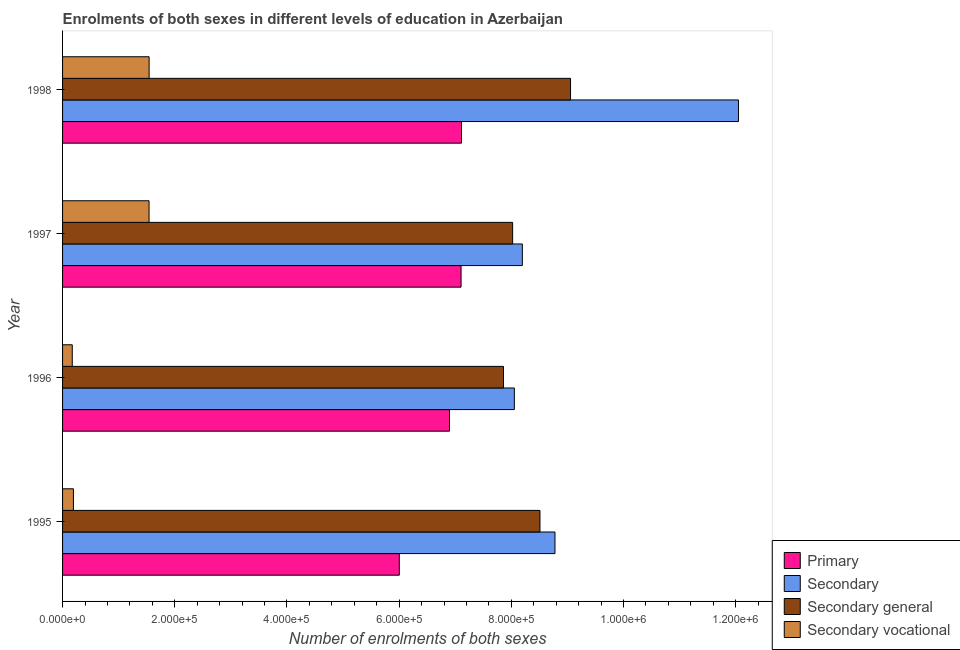Are the number of bars on each tick of the Y-axis equal?
Provide a short and direct response. Yes. How many bars are there on the 3rd tick from the top?
Your response must be concise. 4. How many bars are there on the 4th tick from the bottom?
Your answer should be very brief. 4. In how many cases, is the number of bars for a given year not equal to the number of legend labels?
Give a very brief answer. 0. What is the number of enrolments in secondary education in 1998?
Your answer should be very brief. 1.20e+06. Across all years, what is the maximum number of enrolments in secondary vocational education?
Give a very brief answer. 1.54e+05. Across all years, what is the minimum number of enrolments in primary education?
Your answer should be very brief. 6.00e+05. In which year was the number of enrolments in primary education maximum?
Offer a very short reply. 1998. What is the total number of enrolments in primary education in the graph?
Ensure brevity in your answer.  2.71e+06. What is the difference between the number of enrolments in secondary general education in 1996 and that in 1997?
Give a very brief answer. -1.63e+04. What is the difference between the number of enrolments in secondary education in 1996 and the number of enrolments in secondary vocational education in 1998?
Offer a very short reply. 6.51e+05. What is the average number of enrolments in secondary general education per year?
Your answer should be compact. 8.36e+05. In the year 1998, what is the difference between the number of enrolments in secondary education and number of enrolments in secondary general education?
Your response must be concise. 2.99e+05. In how many years, is the number of enrolments in primary education greater than 920000 ?
Your answer should be very brief. 0. What is the ratio of the number of enrolments in secondary general education in 1996 to that in 1997?
Your answer should be compact. 0.98. Is the number of enrolments in secondary education in 1995 less than that in 1996?
Your answer should be compact. No. What is the difference between the highest and the second highest number of enrolments in secondary education?
Give a very brief answer. 3.27e+05. What is the difference between the highest and the lowest number of enrolments in secondary education?
Keep it short and to the point. 4.00e+05. Is the sum of the number of enrolments in primary education in 1996 and 1998 greater than the maximum number of enrolments in secondary vocational education across all years?
Keep it short and to the point. Yes. What does the 2nd bar from the top in 1997 represents?
Your answer should be very brief. Secondary general. What does the 1st bar from the bottom in 1997 represents?
Provide a succinct answer. Primary. Is it the case that in every year, the sum of the number of enrolments in primary education and number of enrolments in secondary education is greater than the number of enrolments in secondary general education?
Provide a short and direct response. Yes. How many bars are there?
Give a very brief answer. 16. Are all the bars in the graph horizontal?
Give a very brief answer. Yes. Are the values on the major ticks of X-axis written in scientific E-notation?
Your response must be concise. Yes. Where does the legend appear in the graph?
Your response must be concise. Bottom right. How many legend labels are there?
Give a very brief answer. 4. How are the legend labels stacked?
Give a very brief answer. Vertical. What is the title of the graph?
Keep it short and to the point. Enrolments of both sexes in different levels of education in Azerbaijan. What is the label or title of the X-axis?
Provide a short and direct response. Number of enrolments of both sexes. What is the Number of enrolments of both sexes in Primary in 1995?
Your answer should be compact. 6.00e+05. What is the Number of enrolments of both sexes in Secondary in 1995?
Keep it short and to the point. 8.78e+05. What is the Number of enrolments of both sexes in Secondary general in 1995?
Offer a terse response. 8.51e+05. What is the Number of enrolments of both sexes of Secondary vocational in 1995?
Keep it short and to the point. 1.94e+04. What is the Number of enrolments of both sexes of Primary in 1996?
Your response must be concise. 6.90e+05. What is the Number of enrolments of both sexes in Secondary in 1996?
Give a very brief answer. 8.05e+05. What is the Number of enrolments of both sexes of Secondary general in 1996?
Ensure brevity in your answer.  7.86e+05. What is the Number of enrolments of both sexes of Secondary vocational in 1996?
Offer a very short reply. 1.73e+04. What is the Number of enrolments of both sexes of Primary in 1997?
Your answer should be compact. 7.10e+05. What is the Number of enrolments of both sexes of Secondary in 1997?
Make the answer very short. 8.20e+05. What is the Number of enrolments of both sexes of Secondary general in 1997?
Offer a terse response. 8.02e+05. What is the Number of enrolments of both sexes in Secondary vocational in 1997?
Your response must be concise. 1.54e+05. What is the Number of enrolments of both sexes in Primary in 1998?
Offer a very short reply. 7.11e+05. What is the Number of enrolments of both sexes in Secondary in 1998?
Offer a very short reply. 1.20e+06. What is the Number of enrolments of both sexes of Secondary general in 1998?
Keep it short and to the point. 9.06e+05. What is the Number of enrolments of both sexes in Secondary vocational in 1998?
Your answer should be very brief. 1.54e+05. Across all years, what is the maximum Number of enrolments of both sexes of Primary?
Give a very brief answer. 7.11e+05. Across all years, what is the maximum Number of enrolments of both sexes in Secondary?
Provide a short and direct response. 1.20e+06. Across all years, what is the maximum Number of enrolments of both sexes in Secondary general?
Your answer should be very brief. 9.06e+05. Across all years, what is the maximum Number of enrolments of both sexes of Secondary vocational?
Keep it short and to the point. 1.54e+05. Across all years, what is the minimum Number of enrolments of both sexes of Primary?
Give a very brief answer. 6.00e+05. Across all years, what is the minimum Number of enrolments of both sexes of Secondary?
Ensure brevity in your answer.  8.05e+05. Across all years, what is the minimum Number of enrolments of both sexes in Secondary general?
Offer a very short reply. 7.86e+05. Across all years, what is the minimum Number of enrolments of both sexes of Secondary vocational?
Offer a very short reply. 1.73e+04. What is the total Number of enrolments of both sexes of Primary in the graph?
Keep it short and to the point. 2.71e+06. What is the total Number of enrolments of both sexes of Secondary in the graph?
Ensure brevity in your answer.  3.71e+06. What is the total Number of enrolments of both sexes of Secondary general in the graph?
Give a very brief answer. 3.34e+06. What is the total Number of enrolments of both sexes in Secondary vocational in the graph?
Your answer should be compact. 3.45e+05. What is the difference between the Number of enrolments of both sexes in Primary in 1995 and that in 1996?
Give a very brief answer. -8.94e+04. What is the difference between the Number of enrolments of both sexes in Secondary in 1995 and that in 1996?
Your answer should be very brief. 7.24e+04. What is the difference between the Number of enrolments of both sexes in Secondary general in 1995 and that in 1996?
Keep it short and to the point. 6.50e+04. What is the difference between the Number of enrolments of both sexes of Secondary vocational in 1995 and that in 1996?
Your response must be concise. 2070. What is the difference between the Number of enrolments of both sexes in Primary in 1995 and that in 1997?
Your answer should be very brief. -1.10e+05. What is the difference between the Number of enrolments of both sexes in Secondary in 1995 and that in 1997?
Offer a terse response. 5.82e+04. What is the difference between the Number of enrolments of both sexes in Secondary general in 1995 and that in 1997?
Provide a succinct answer. 4.87e+04. What is the difference between the Number of enrolments of both sexes of Secondary vocational in 1995 and that in 1997?
Your answer should be compact. -1.35e+05. What is the difference between the Number of enrolments of both sexes in Primary in 1995 and that in 1998?
Give a very brief answer. -1.11e+05. What is the difference between the Number of enrolments of both sexes of Secondary in 1995 and that in 1998?
Your response must be concise. -3.27e+05. What is the difference between the Number of enrolments of both sexes in Secondary general in 1995 and that in 1998?
Provide a succinct answer. -5.45e+04. What is the difference between the Number of enrolments of both sexes in Secondary vocational in 1995 and that in 1998?
Your answer should be very brief. -1.35e+05. What is the difference between the Number of enrolments of both sexes in Primary in 1996 and that in 1997?
Your answer should be compact. -2.06e+04. What is the difference between the Number of enrolments of both sexes in Secondary in 1996 and that in 1997?
Your answer should be very brief. -1.42e+04. What is the difference between the Number of enrolments of both sexes in Secondary general in 1996 and that in 1997?
Provide a succinct answer. -1.63e+04. What is the difference between the Number of enrolments of both sexes of Secondary vocational in 1996 and that in 1997?
Ensure brevity in your answer.  -1.37e+05. What is the difference between the Number of enrolments of both sexes in Primary in 1996 and that in 1998?
Your response must be concise. -2.14e+04. What is the difference between the Number of enrolments of both sexes in Secondary in 1996 and that in 1998?
Provide a short and direct response. -4.00e+05. What is the difference between the Number of enrolments of both sexes in Secondary general in 1996 and that in 1998?
Your response must be concise. -1.20e+05. What is the difference between the Number of enrolments of both sexes in Secondary vocational in 1996 and that in 1998?
Your response must be concise. -1.37e+05. What is the difference between the Number of enrolments of both sexes of Primary in 1997 and that in 1998?
Your response must be concise. -738. What is the difference between the Number of enrolments of both sexes of Secondary in 1997 and that in 1998?
Keep it short and to the point. -3.85e+05. What is the difference between the Number of enrolments of both sexes in Secondary general in 1997 and that in 1998?
Your answer should be compact. -1.03e+05. What is the difference between the Number of enrolments of both sexes in Secondary vocational in 1997 and that in 1998?
Offer a very short reply. -114. What is the difference between the Number of enrolments of both sexes of Primary in 1995 and the Number of enrolments of both sexes of Secondary in 1996?
Your answer should be compact. -2.05e+05. What is the difference between the Number of enrolments of both sexes in Primary in 1995 and the Number of enrolments of both sexes in Secondary general in 1996?
Make the answer very short. -1.86e+05. What is the difference between the Number of enrolments of both sexes of Primary in 1995 and the Number of enrolments of both sexes of Secondary vocational in 1996?
Your answer should be compact. 5.83e+05. What is the difference between the Number of enrolments of both sexes of Secondary in 1995 and the Number of enrolments of both sexes of Secondary general in 1996?
Your answer should be compact. 9.18e+04. What is the difference between the Number of enrolments of both sexes of Secondary in 1995 and the Number of enrolments of both sexes of Secondary vocational in 1996?
Your answer should be compact. 8.61e+05. What is the difference between the Number of enrolments of both sexes of Secondary general in 1995 and the Number of enrolments of both sexes of Secondary vocational in 1996?
Offer a very short reply. 8.34e+05. What is the difference between the Number of enrolments of both sexes in Primary in 1995 and the Number of enrolments of both sexes in Secondary in 1997?
Offer a terse response. -2.19e+05. What is the difference between the Number of enrolments of both sexes in Primary in 1995 and the Number of enrolments of both sexes in Secondary general in 1997?
Make the answer very short. -2.02e+05. What is the difference between the Number of enrolments of both sexes of Primary in 1995 and the Number of enrolments of both sexes of Secondary vocational in 1997?
Keep it short and to the point. 4.46e+05. What is the difference between the Number of enrolments of both sexes of Secondary in 1995 and the Number of enrolments of both sexes of Secondary general in 1997?
Keep it short and to the point. 7.55e+04. What is the difference between the Number of enrolments of both sexes of Secondary in 1995 and the Number of enrolments of both sexes of Secondary vocational in 1997?
Offer a very short reply. 7.24e+05. What is the difference between the Number of enrolments of both sexes of Secondary general in 1995 and the Number of enrolments of both sexes of Secondary vocational in 1997?
Give a very brief answer. 6.97e+05. What is the difference between the Number of enrolments of both sexes in Primary in 1995 and the Number of enrolments of both sexes in Secondary in 1998?
Give a very brief answer. -6.05e+05. What is the difference between the Number of enrolments of both sexes in Primary in 1995 and the Number of enrolments of both sexes in Secondary general in 1998?
Make the answer very short. -3.05e+05. What is the difference between the Number of enrolments of both sexes in Primary in 1995 and the Number of enrolments of both sexes in Secondary vocational in 1998?
Your response must be concise. 4.46e+05. What is the difference between the Number of enrolments of both sexes in Secondary in 1995 and the Number of enrolments of both sexes in Secondary general in 1998?
Give a very brief answer. -2.77e+04. What is the difference between the Number of enrolments of both sexes in Secondary in 1995 and the Number of enrolments of both sexes in Secondary vocational in 1998?
Your response must be concise. 7.24e+05. What is the difference between the Number of enrolments of both sexes in Secondary general in 1995 and the Number of enrolments of both sexes in Secondary vocational in 1998?
Offer a very short reply. 6.97e+05. What is the difference between the Number of enrolments of both sexes in Primary in 1996 and the Number of enrolments of both sexes in Secondary in 1997?
Provide a succinct answer. -1.30e+05. What is the difference between the Number of enrolments of both sexes of Primary in 1996 and the Number of enrolments of both sexes of Secondary general in 1997?
Offer a terse response. -1.13e+05. What is the difference between the Number of enrolments of both sexes of Primary in 1996 and the Number of enrolments of both sexes of Secondary vocational in 1997?
Make the answer very short. 5.36e+05. What is the difference between the Number of enrolments of both sexes of Secondary in 1996 and the Number of enrolments of both sexes of Secondary general in 1997?
Ensure brevity in your answer.  3044. What is the difference between the Number of enrolments of both sexes of Secondary in 1996 and the Number of enrolments of both sexes of Secondary vocational in 1997?
Your answer should be compact. 6.51e+05. What is the difference between the Number of enrolments of both sexes in Secondary general in 1996 and the Number of enrolments of both sexes in Secondary vocational in 1997?
Offer a very short reply. 6.32e+05. What is the difference between the Number of enrolments of both sexes in Primary in 1996 and the Number of enrolments of both sexes in Secondary in 1998?
Your answer should be compact. -5.15e+05. What is the difference between the Number of enrolments of both sexes in Primary in 1996 and the Number of enrolments of both sexes in Secondary general in 1998?
Your answer should be very brief. -2.16e+05. What is the difference between the Number of enrolments of both sexes in Primary in 1996 and the Number of enrolments of both sexes in Secondary vocational in 1998?
Offer a terse response. 5.35e+05. What is the difference between the Number of enrolments of both sexes in Secondary in 1996 and the Number of enrolments of both sexes in Secondary general in 1998?
Your response must be concise. -1.00e+05. What is the difference between the Number of enrolments of both sexes of Secondary in 1996 and the Number of enrolments of both sexes of Secondary vocational in 1998?
Your answer should be very brief. 6.51e+05. What is the difference between the Number of enrolments of both sexes of Secondary general in 1996 and the Number of enrolments of both sexes of Secondary vocational in 1998?
Your response must be concise. 6.32e+05. What is the difference between the Number of enrolments of both sexes in Primary in 1997 and the Number of enrolments of both sexes in Secondary in 1998?
Make the answer very short. -4.95e+05. What is the difference between the Number of enrolments of both sexes of Primary in 1997 and the Number of enrolments of both sexes of Secondary general in 1998?
Give a very brief answer. -1.95e+05. What is the difference between the Number of enrolments of both sexes in Primary in 1997 and the Number of enrolments of both sexes in Secondary vocational in 1998?
Ensure brevity in your answer.  5.56e+05. What is the difference between the Number of enrolments of both sexes of Secondary in 1997 and the Number of enrolments of both sexes of Secondary general in 1998?
Your answer should be compact. -8.59e+04. What is the difference between the Number of enrolments of both sexes in Secondary in 1997 and the Number of enrolments of both sexes in Secondary vocational in 1998?
Offer a very short reply. 6.65e+05. What is the difference between the Number of enrolments of both sexes in Secondary general in 1997 and the Number of enrolments of both sexes in Secondary vocational in 1998?
Keep it short and to the point. 6.48e+05. What is the average Number of enrolments of both sexes in Primary per year?
Your answer should be very brief. 6.78e+05. What is the average Number of enrolments of both sexes of Secondary per year?
Provide a short and direct response. 9.27e+05. What is the average Number of enrolments of both sexes of Secondary general per year?
Offer a terse response. 8.36e+05. What is the average Number of enrolments of both sexes of Secondary vocational per year?
Give a very brief answer. 8.63e+04. In the year 1995, what is the difference between the Number of enrolments of both sexes of Primary and Number of enrolments of both sexes of Secondary?
Offer a very short reply. -2.77e+05. In the year 1995, what is the difference between the Number of enrolments of both sexes in Primary and Number of enrolments of both sexes in Secondary general?
Provide a succinct answer. -2.51e+05. In the year 1995, what is the difference between the Number of enrolments of both sexes of Primary and Number of enrolments of both sexes of Secondary vocational?
Provide a short and direct response. 5.81e+05. In the year 1995, what is the difference between the Number of enrolments of both sexes of Secondary and Number of enrolments of both sexes of Secondary general?
Your response must be concise. 2.68e+04. In the year 1995, what is the difference between the Number of enrolments of both sexes of Secondary and Number of enrolments of both sexes of Secondary vocational?
Your answer should be compact. 8.58e+05. In the year 1995, what is the difference between the Number of enrolments of both sexes of Secondary general and Number of enrolments of both sexes of Secondary vocational?
Provide a succinct answer. 8.32e+05. In the year 1996, what is the difference between the Number of enrolments of both sexes in Primary and Number of enrolments of both sexes in Secondary?
Your response must be concise. -1.16e+05. In the year 1996, what is the difference between the Number of enrolments of both sexes in Primary and Number of enrolments of both sexes in Secondary general?
Make the answer very short. -9.63e+04. In the year 1996, what is the difference between the Number of enrolments of both sexes in Primary and Number of enrolments of both sexes in Secondary vocational?
Ensure brevity in your answer.  6.72e+05. In the year 1996, what is the difference between the Number of enrolments of both sexes of Secondary and Number of enrolments of both sexes of Secondary general?
Keep it short and to the point. 1.94e+04. In the year 1996, what is the difference between the Number of enrolments of both sexes of Secondary and Number of enrolments of both sexes of Secondary vocational?
Provide a succinct answer. 7.88e+05. In the year 1996, what is the difference between the Number of enrolments of both sexes in Secondary general and Number of enrolments of both sexes in Secondary vocational?
Offer a terse response. 7.69e+05. In the year 1997, what is the difference between the Number of enrolments of both sexes in Primary and Number of enrolments of both sexes in Secondary?
Keep it short and to the point. -1.09e+05. In the year 1997, what is the difference between the Number of enrolments of both sexes in Primary and Number of enrolments of both sexes in Secondary general?
Your response must be concise. -9.19e+04. In the year 1997, what is the difference between the Number of enrolments of both sexes in Primary and Number of enrolments of both sexes in Secondary vocational?
Your answer should be compact. 5.56e+05. In the year 1997, what is the difference between the Number of enrolments of both sexes of Secondary and Number of enrolments of both sexes of Secondary general?
Provide a succinct answer. 1.73e+04. In the year 1997, what is the difference between the Number of enrolments of both sexes of Secondary and Number of enrolments of both sexes of Secondary vocational?
Provide a short and direct response. 6.65e+05. In the year 1997, what is the difference between the Number of enrolments of both sexes of Secondary general and Number of enrolments of both sexes of Secondary vocational?
Your answer should be compact. 6.48e+05. In the year 1998, what is the difference between the Number of enrolments of both sexes in Primary and Number of enrolments of both sexes in Secondary?
Give a very brief answer. -4.94e+05. In the year 1998, what is the difference between the Number of enrolments of both sexes of Primary and Number of enrolments of both sexes of Secondary general?
Provide a succinct answer. -1.94e+05. In the year 1998, what is the difference between the Number of enrolments of both sexes in Primary and Number of enrolments of both sexes in Secondary vocational?
Offer a terse response. 5.57e+05. In the year 1998, what is the difference between the Number of enrolments of both sexes in Secondary and Number of enrolments of both sexes in Secondary general?
Your answer should be very brief. 2.99e+05. In the year 1998, what is the difference between the Number of enrolments of both sexes of Secondary and Number of enrolments of both sexes of Secondary vocational?
Keep it short and to the point. 1.05e+06. In the year 1998, what is the difference between the Number of enrolments of both sexes in Secondary general and Number of enrolments of both sexes in Secondary vocational?
Offer a terse response. 7.51e+05. What is the ratio of the Number of enrolments of both sexes in Primary in 1995 to that in 1996?
Ensure brevity in your answer.  0.87. What is the ratio of the Number of enrolments of both sexes in Secondary in 1995 to that in 1996?
Provide a short and direct response. 1.09. What is the ratio of the Number of enrolments of both sexes in Secondary general in 1995 to that in 1996?
Your answer should be compact. 1.08. What is the ratio of the Number of enrolments of both sexes of Secondary vocational in 1995 to that in 1996?
Give a very brief answer. 1.12. What is the ratio of the Number of enrolments of both sexes of Primary in 1995 to that in 1997?
Provide a short and direct response. 0.85. What is the ratio of the Number of enrolments of both sexes in Secondary in 1995 to that in 1997?
Offer a terse response. 1.07. What is the ratio of the Number of enrolments of both sexes in Secondary general in 1995 to that in 1997?
Your answer should be compact. 1.06. What is the ratio of the Number of enrolments of both sexes of Secondary vocational in 1995 to that in 1997?
Provide a short and direct response. 0.13. What is the ratio of the Number of enrolments of both sexes in Primary in 1995 to that in 1998?
Make the answer very short. 0.84. What is the ratio of the Number of enrolments of both sexes of Secondary in 1995 to that in 1998?
Provide a short and direct response. 0.73. What is the ratio of the Number of enrolments of both sexes in Secondary general in 1995 to that in 1998?
Offer a terse response. 0.94. What is the ratio of the Number of enrolments of both sexes of Secondary vocational in 1995 to that in 1998?
Provide a short and direct response. 0.13. What is the ratio of the Number of enrolments of both sexes of Primary in 1996 to that in 1997?
Provide a succinct answer. 0.97. What is the ratio of the Number of enrolments of both sexes of Secondary in 1996 to that in 1997?
Give a very brief answer. 0.98. What is the ratio of the Number of enrolments of both sexes in Secondary general in 1996 to that in 1997?
Provide a succinct answer. 0.98. What is the ratio of the Number of enrolments of both sexes in Secondary vocational in 1996 to that in 1997?
Offer a terse response. 0.11. What is the ratio of the Number of enrolments of both sexes in Primary in 1996 to that in 1998?
Offer a terse response. 0.97. What is the ratio of the Number of enrolments of both sexes of Secondary in 1996 to that in 1998?
Give a very brief answer. 0.67. What is the ratio of the Number of enrolments of both sexes in Secondary general in 1996 to that in 1998?
Offer a terse response. 0.87. What is the ratio of the Number of enrolments of both sexes of Secondary vocational in 1996 to that in 1998?
Make the answer very short. 0.11. What is the ratio of the Number of enrolments of both sexes of Secondary in 1997 to that in 1998?
Give a very brief answer. 0.68. What is the ratio of the Number of enrolments of both sexes in Secondary general in 1997 to that in 1998?
Offer a very short reply. 0.89. What is the difference between the highest and the second highest Number of enrolments of both sexes in Primary?
Keep it short and to the point. 738. What is the difference between the highest and the second highest Number of enrolments of both sexes of Secondary?
Offer a very short reply. 3.27e+05. What is the difference between the highest and the second highest Number of enrolments of both sexes of Secondary general?
Your answer should be compact. 5.45e+04. What is the difference between the highest and the second highest Number of enrolments of both sexes in Secondary vocational?
Your response must be concise. 114. What is the difference between the highest and the lowest Number of enrolments of both sexes in Primary?
Provide a short and direct response. 1.11e+05. What is the difference between the highest and the lowest Number of enrolments of both sexes in Secondary?
Give a very brief answer. 4.00e+05. What is the difference between the highest and the lowest Number of enrolments of both sexes in Secondary general?
Provide a succinct answer. 1.20e+05. What is the difference between the highest and the lowest Number of enrolments of both sexes in Secondary vocational?
Offer a terse response. 1.37e+05. 